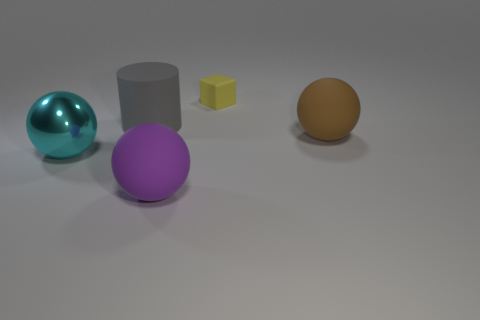Are there an equal number of cyan balls on the right side of the purple matte sphere and big cyan metallic things in front of the brown matte sphere? Yes, there is one cyan ball on the right side of the purple matte sphere and one large cyan metallic sphere in front of the brown matte sphere, making the number of items in each specified location equal. 